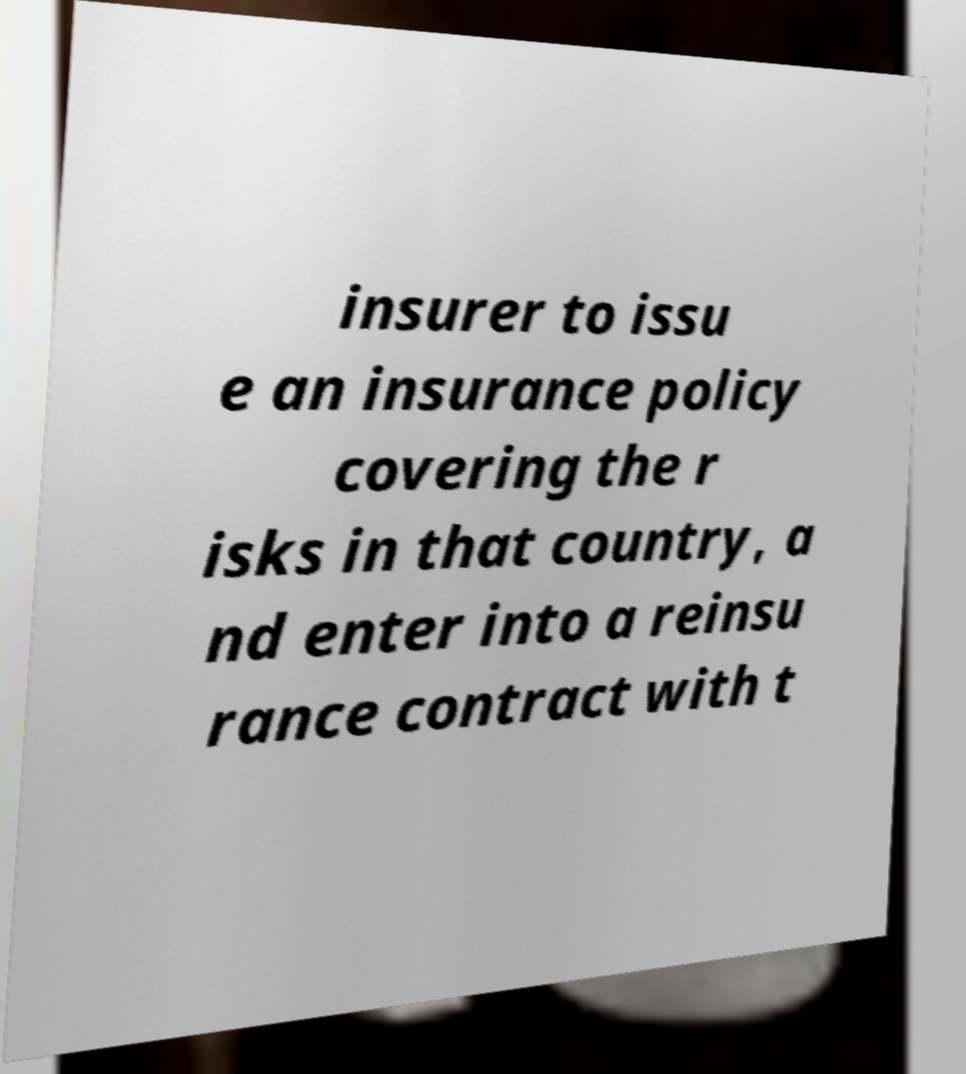I need the written content from this picture converted into text. Can you do that? insurer to issu e an insurance policy covering the r isks in that country, a nd enter into a reinsu rance contract with t 